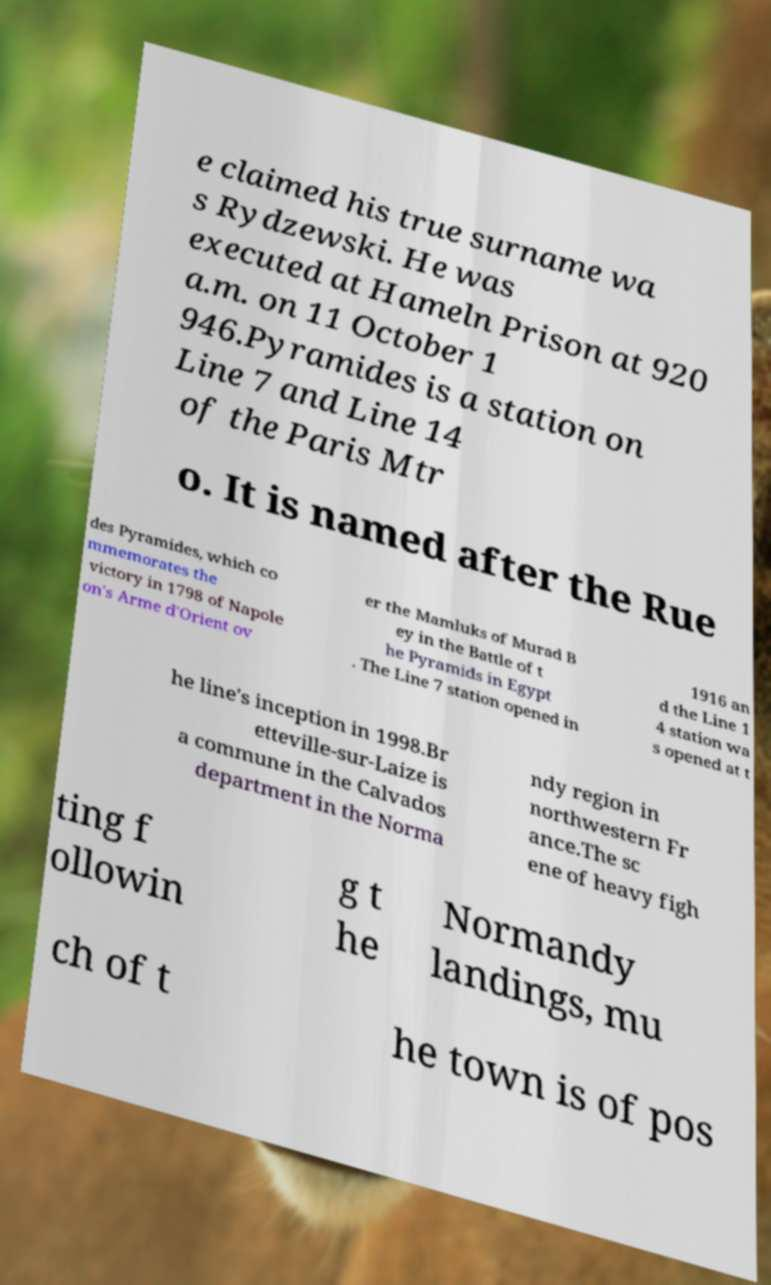Could you assist in decoding the text presented in this image and type it out clearly? e claimed his true surname wa s Rydzewski. He was executed at Hameln Prison at 920 a.m. on 11 October 1 946.Pyramides is a station on Line 7 and Line 14 of the Paris Mtr o. It is named after the Rue des Pyramides, which co mmemorates the victory in 1798 of Napole on's Arme d'Orient ov er the Mamluks of Murad B ey in the Battle of t he Pyramids in Egypt . The Line 7 station opened in 1916 an d the Line 1 4 station wa s opened at t he line's inception in 1998.Br etteville-sur-Laize is a commune in the Calvados department in the Norma ndy region in northwestern Fr ance.The sc ene of heavy figh ting f ollowin g t he Normandy landings, mu ch of t he town is of pos 